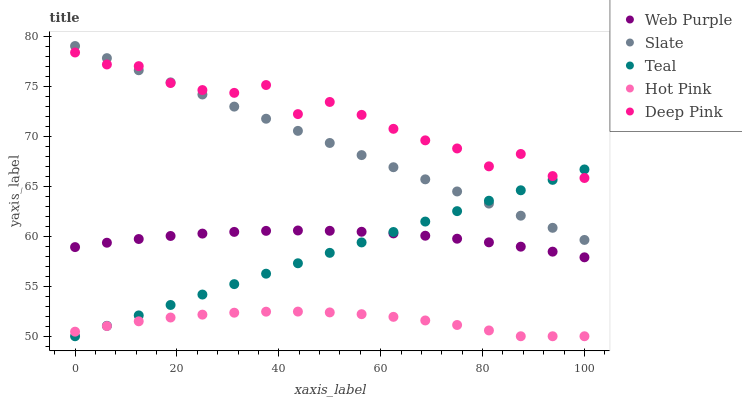Does Hot Pink have the minimum area under the curve?
Answer yes or no. Yes. Does Deep Pink have the maximum area under the curve?
Answer yes or no. Yes. Does Slate have the minimum area under the curve?
Answer yes or no. No. Does Slate have the maximum area under the curve?
Answer yes or no. No. Is Teal the smoothest?
Answer yes or no. Yes. Is Deep Pink the roughest?
Answer yes or no. Yes. Is Hot Pink the smoothest?
Answer yes or no. No. Is Hot Pink the roughest?
Answer yes or no. No. Does Hot Pink have the lowest value?
Answer yes or no. Yes. Does Slate have the lowest value?
Answer yes or no. No. Does Slate have the highest value?
Answer yes or no. Yes. Does Hot Pink have the highest value?
Answer yes or no. No. Is Web Purple less than Slate?
Answer yes or no. Yes. Is Web Purple greater than Hot Pink?
Answer yes or no. Yes. Does Teal intersect Web Purple?
Answer yes or no. Yes. Is Teal less than Web Purple?
Answer yes or no. No. Is Teal greater than Web Purple?
Answer yes or no. No. Does Web Purple intersect Slate?
Answer yes or no. No. 